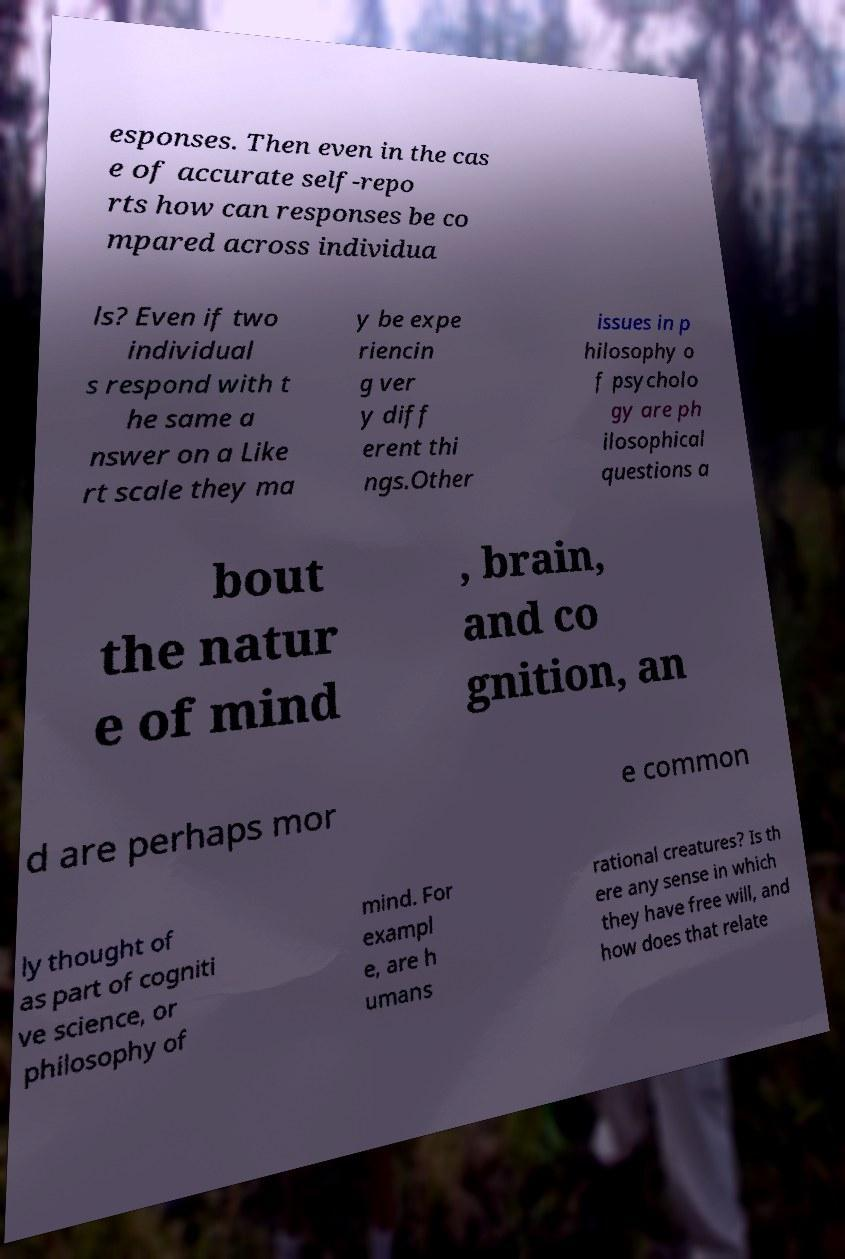Can you read and provide the text displayed in the image?This photo seems to have some interesting text. Can you extract and type it out for me? esponses. Then even in the cas e of accurate self-repo rts how can responses be co mpared across individua ls? Even if two individual s respond with t he same a nswer on a Like rt scale they ma y be expe riencin g ver y diff erent thi ngs.Other issues in p hilosophy o f psycholo gy are ph ilosophical questions a bout the natur e of mind , brain, and co gnition, an d are perhaps mor e common ly thought of as part of cogniti ve science, or philosophy of mind. For exampl e, are h umans rational creatures? Is th ere any sense in which they have free will, and how does that relate 